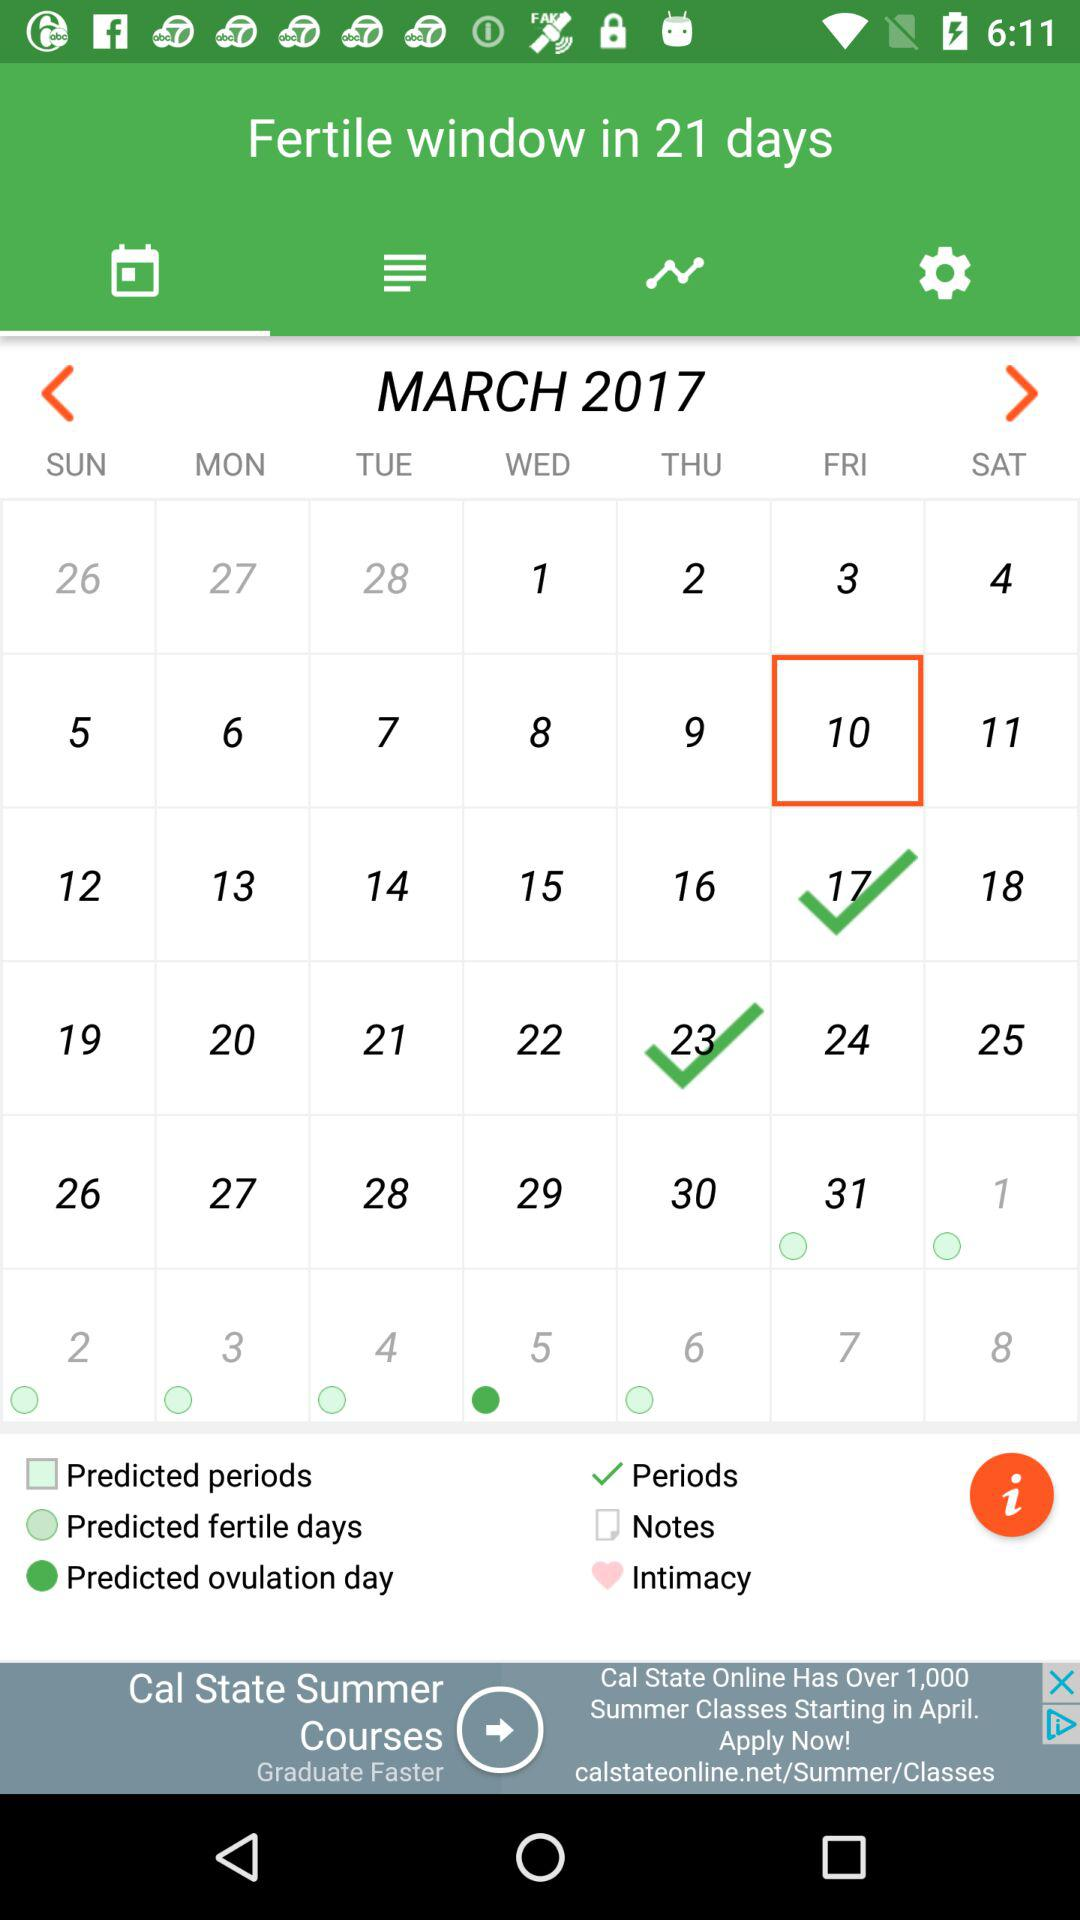What day is it on March 10, 2017? The day is Friday. 